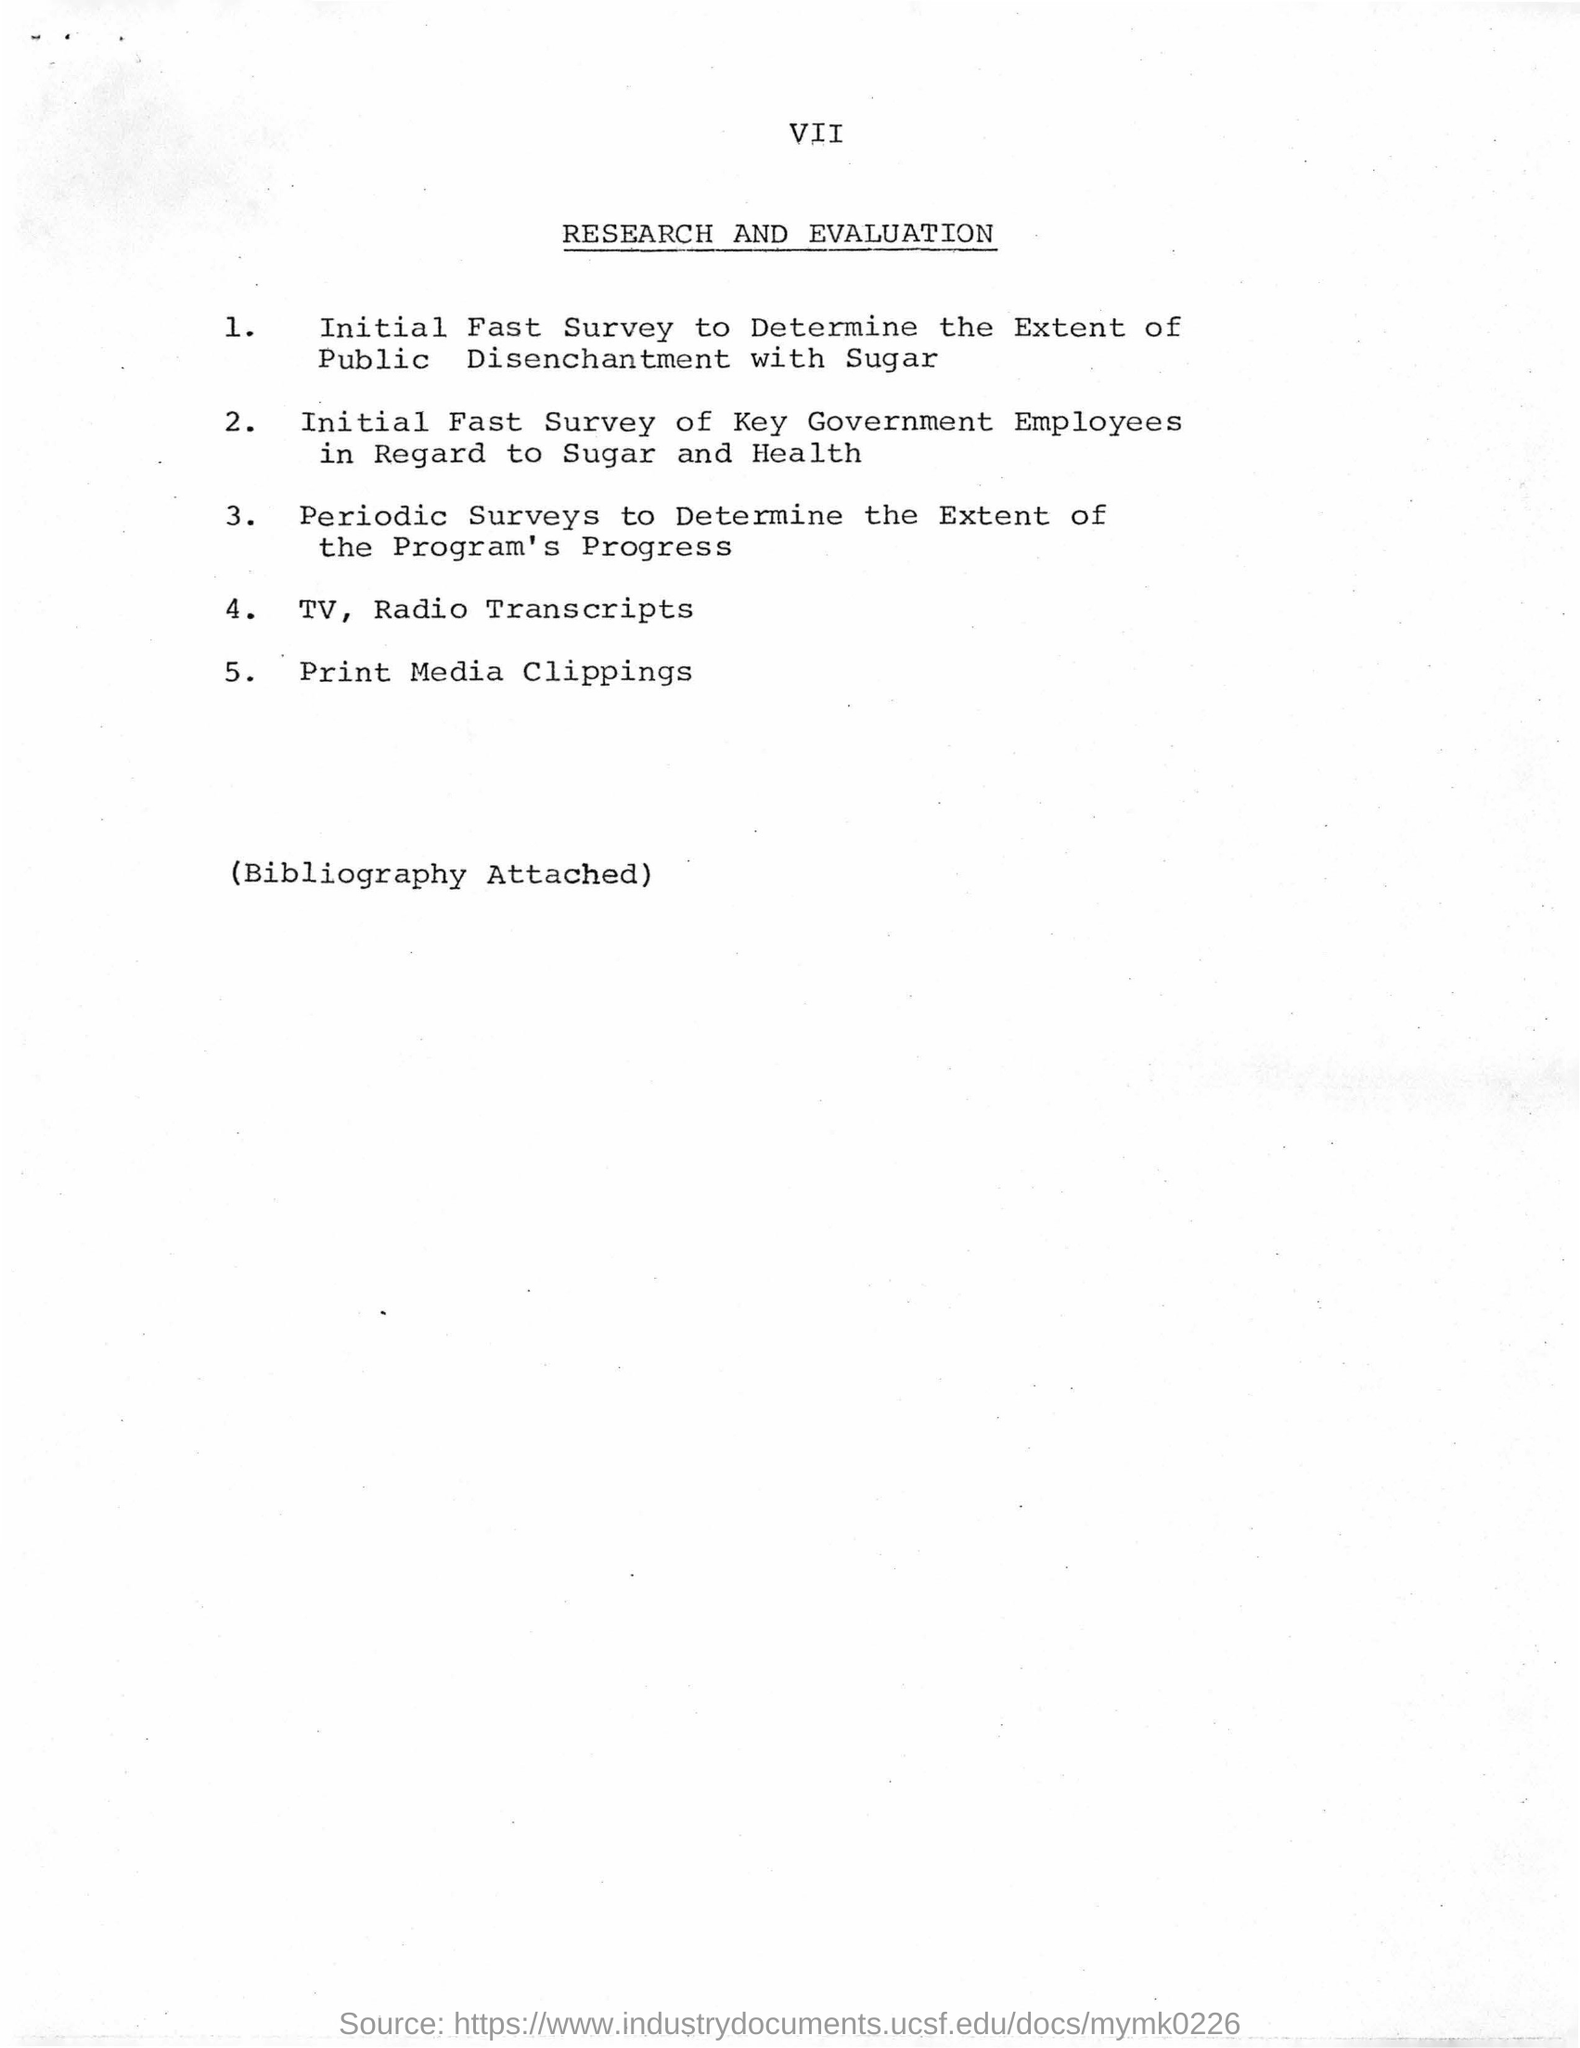What is 4th item in the list?
Ensure brevity in your answer.  4. TV, Radio Transcripts. What is the title of this sheet?
Offer a terse response. Research and evaluation. 